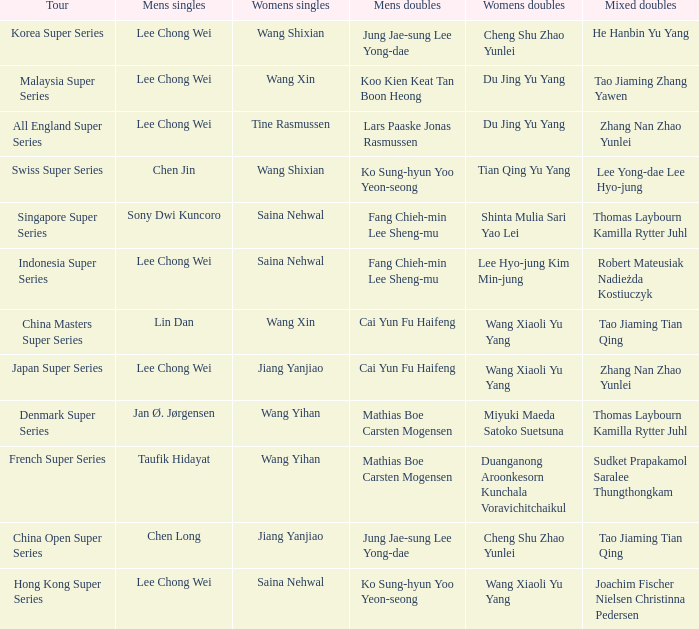Who is the mixed doubled on the tour korea super series? He Hanbin Yu Yang. 